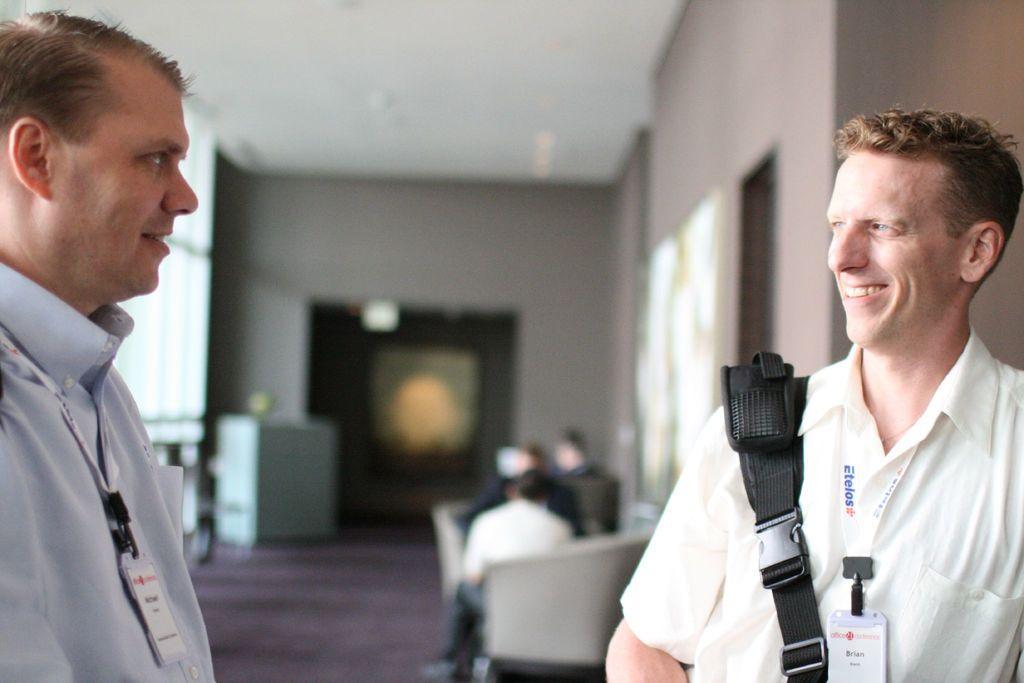In one or two sentences, can you explain what this image depicts? In this image there is a person on the right side who is wearing the bag. On the left side there is another person who is standing on the floor. In the background there are few people sitting in the chairs. In the middle there is a door. On the left side, there is a cupboard in the background. At the top there is ceiling. On the right side there is a wall on which there are two frames. 